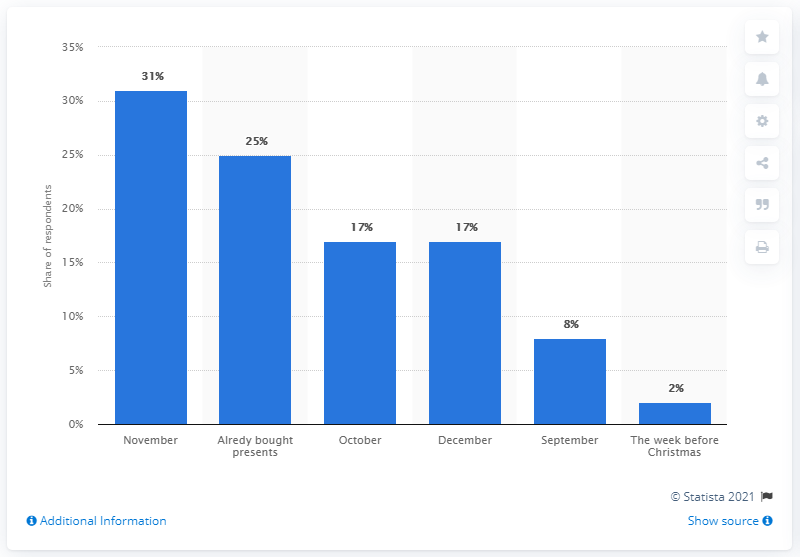Identify some key points in this picture. The majority of consumers in the UK plan to do their Christmas shopping in November. 